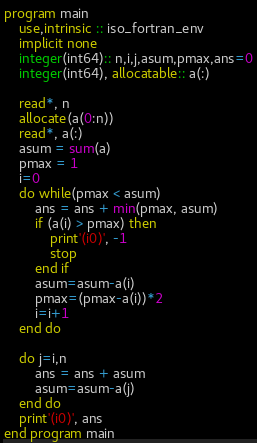Convert code to text. <code><loc_0><loc_0><loc_500><loc_500><_FORTRAN_>program main
    use,intrinsic :: iso_fortran_env
    implicit none
    integer(int64):: n,i,j,asum,pmax,ans=0
    integer(int64), allocatable:: a(:)

    read*, n
    allocate(a(0:n))
    read*, a(:)
    asum = sum(a)
    pmax = 1
    i=0
    do while(pmax < asum)
        ans = ans + min(pmax, asum)
        if (a(i) > pmax) then
            print'(i0)', -1
            stop
        end if
        asum=asum-a(i)
        pmax=(pmax-a(i))*2
        i=i+1
    end do

    do j=i,n
        ans = ans + asum
        asum=asum-a(j)
    end do
    print'(i0)', ans
end program main</code> 